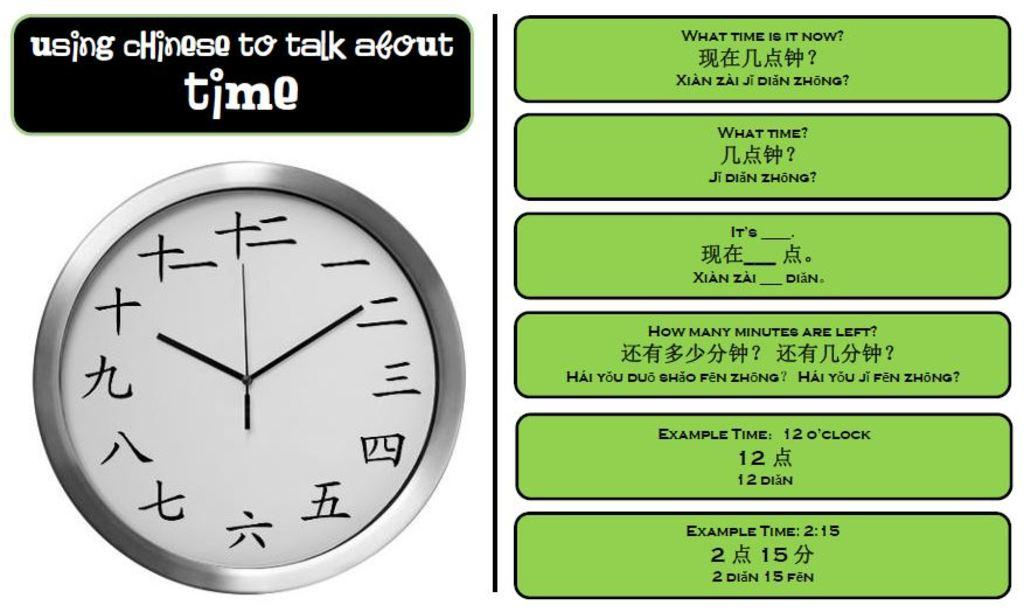<image>
Give a short and clear explanation of the subsequent image. A clock with Chinese characters is below a text box that says "using Chinese to talk about time." 